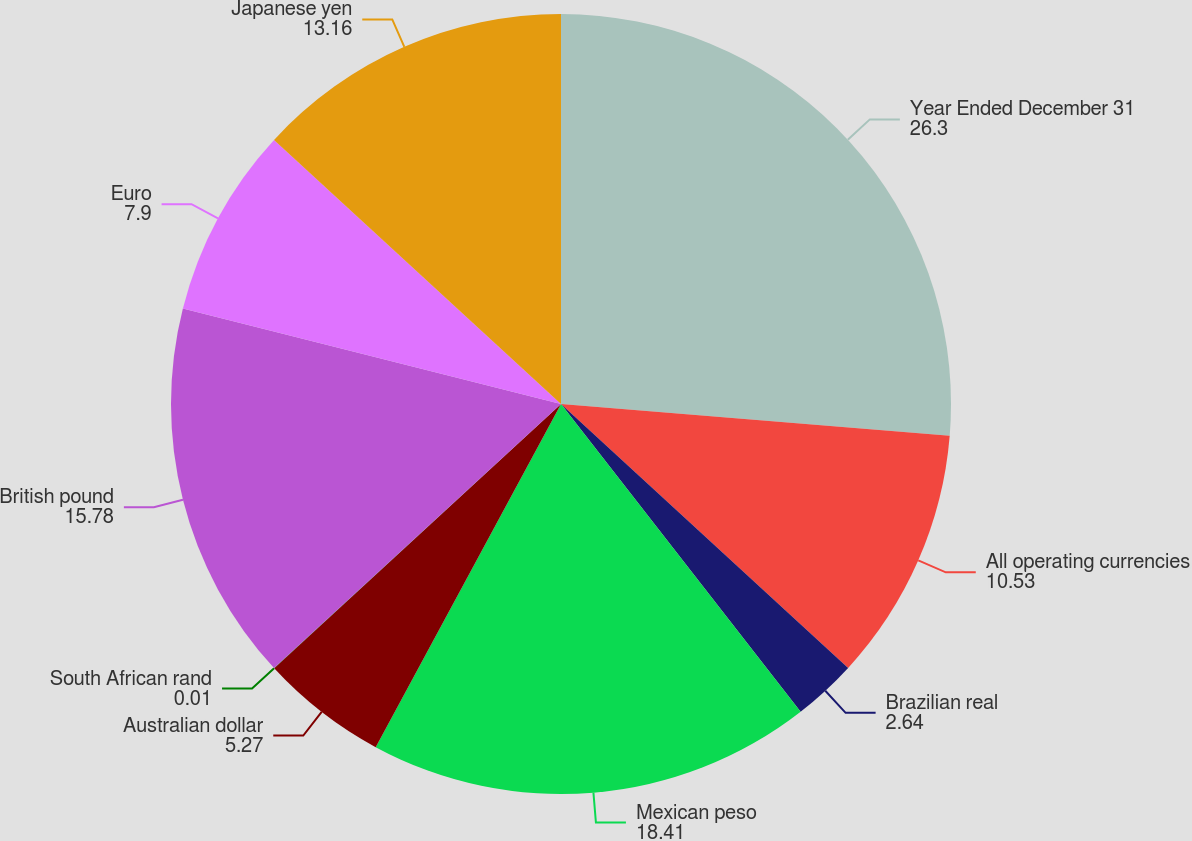<chart> <loc_0><loc_0><loc_500><loc_500><pie_chart><fcel>Year Ended December 31<fcel>All operating currencies<fcel>Brazilian real<fcel>Mexican peso<fcel>Australian dollar<fcel>South African rand<fcel>British pound<fcel>Euro<fcel>Japanese yen<nl><fcel>26.3%<fcel>10.53%<fcel>2.64%<fcel>18.41%<fcel>5.27%<fcel>0.01%<fcel>15.78%<fcel>7.9%<fcel>13.16%<nl></chart> 